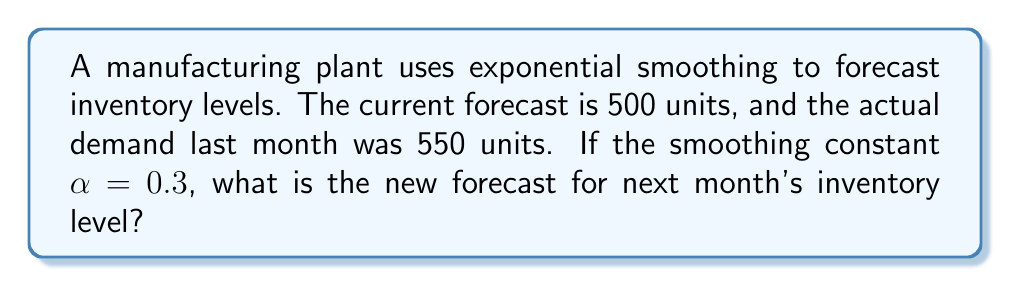Can you answer this question? To solve this problem, we'll use the exponential smoothing formula:

$$F_{t+1} = \alpha D_t + (1-\alpha)F_t$$

Where:
$F_{t+1}$ = New forecast for next period
$\alpha$ = Smoothing constant
$D_t$ = Actual demand in current period
$F_t$ = Previous forecast for current period

Given:
$\alpha = 0.3$
$D_t = 550$ units (actual demand last month)
$F_t = 500$ units (current forecast)

Let's substitute these values into the formula:

$$F_{t+1} = 0.3 \times 550 + (1-0.3) \times 500$$

Simplifying:

$$F_{t+1} = 165 + 0.7 \times 500$$
$$F_{t+1} = 165 + 350$$
$$F_{t+1} = 515$$

Therefore, the new forecast for next month's inventory level is 515 units.

This method helps reduce waste in production by adjusting inventory forecasts based on recent demand, allowing for more accurate planning and less overproduction or stockouts.
Answer: 515 units 